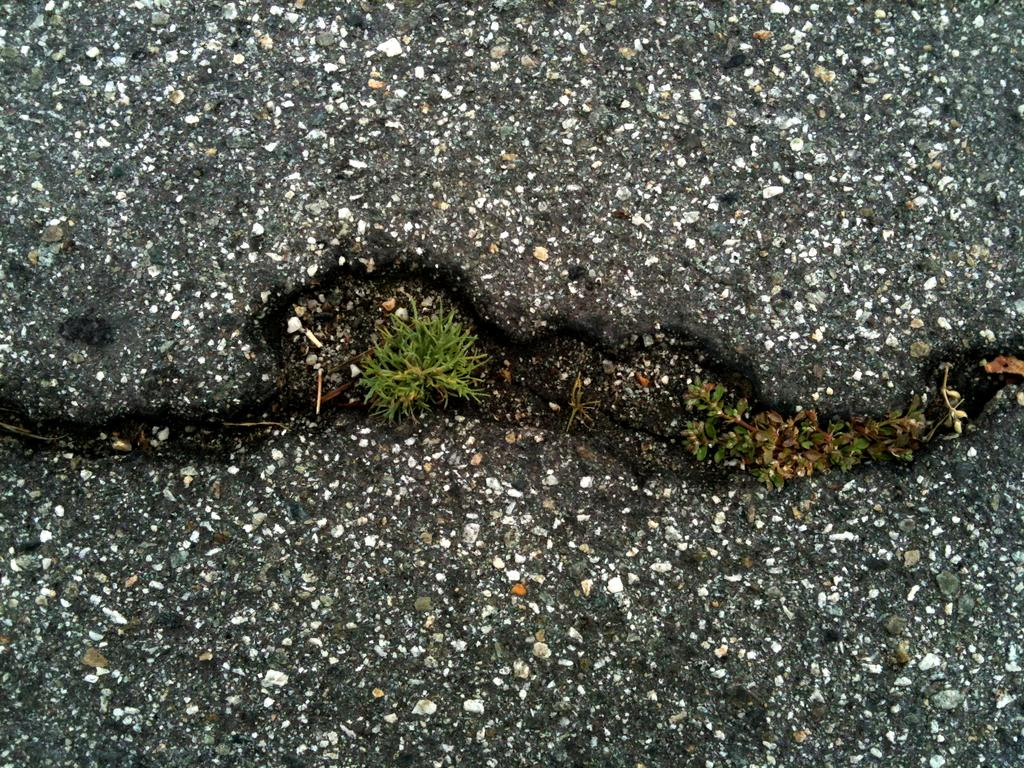What color is the grass in the image? The grass in the image is green. Can you describe the colors in the background of the image? The background of the image has brown, black, and white colors. Where is the pan located in the image? There is no pan present in the image. What is the mother doing in the image? There is no mother or any person present in the image. 